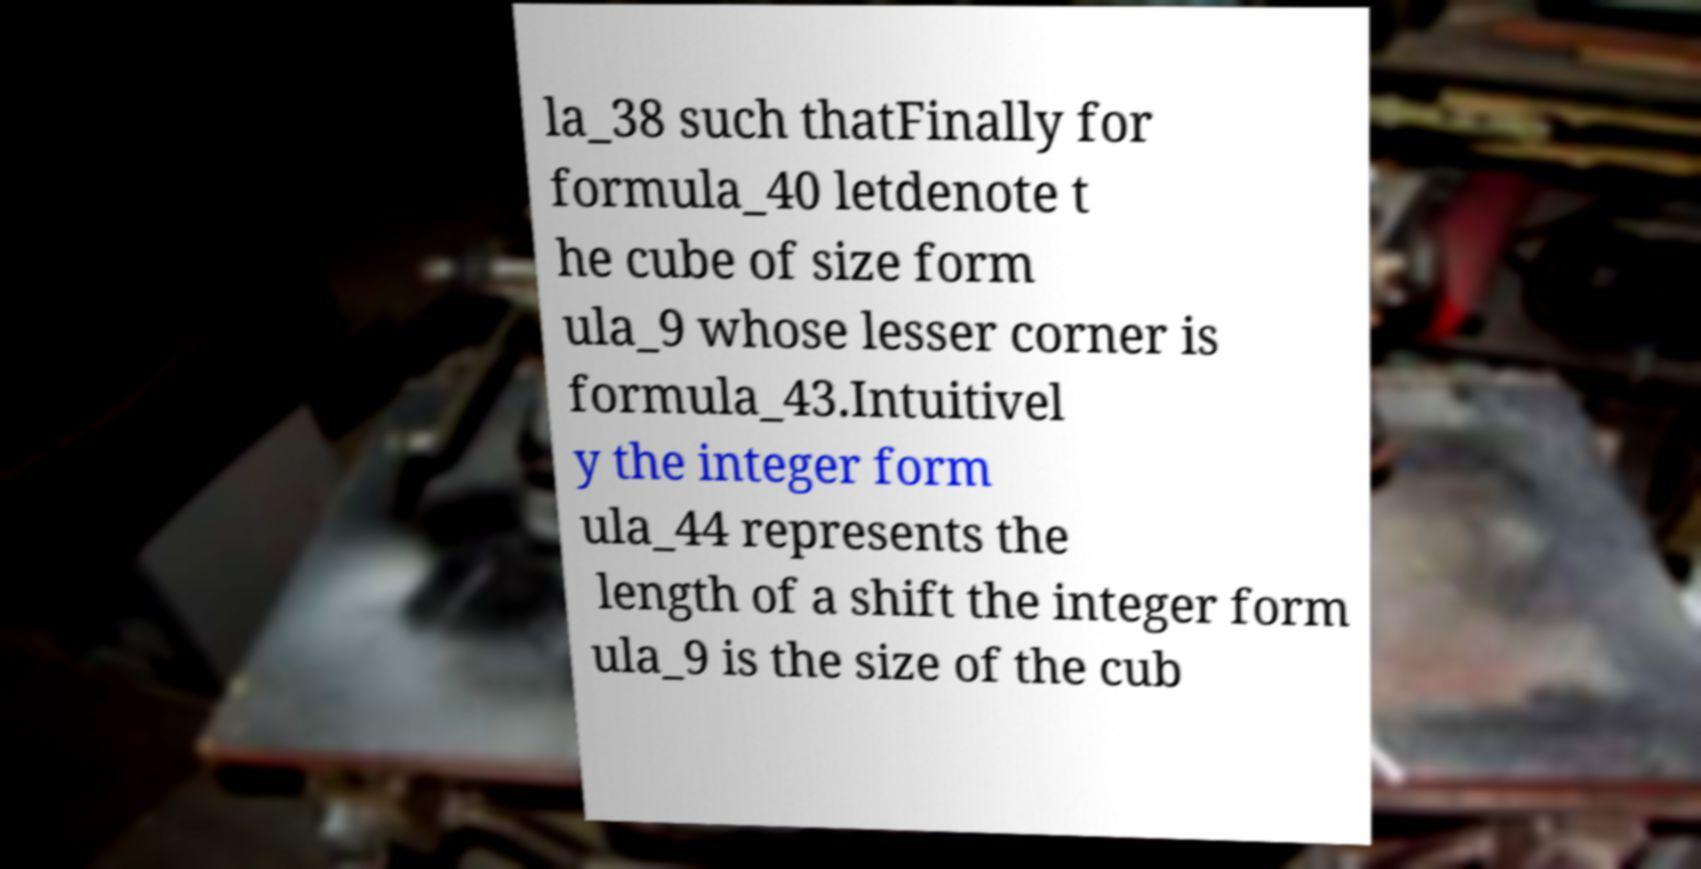Please identify and transcribe the text found in this image. la_38 such thatFinally for formula_40 letdenote t he cube of size form ula_9 whose lesser corner is formula_43.Intuitivel y the integer form ula_44 represents the length of a shift the integer form ula_9 is the size of the cub 